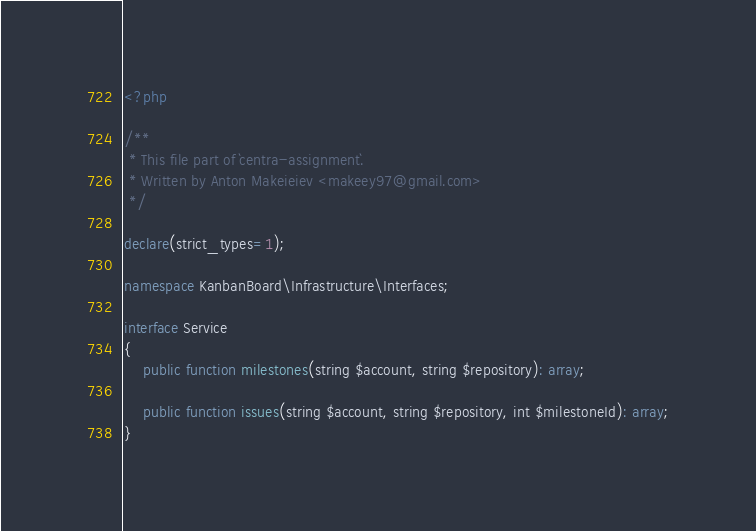Convert code to text. <code><loc_0><loc_0><loc_500><loc_500><_PHP_><?php

/**
 * This file part of `centra-assignment`.
 * Written by Anton Makeieiev <makeey97@gmail.com>
 */

declare(strict_types=1);

namespace KanbanBoard\Infrastructure\Interfaces;

interface Service
{
    public function milestones(string $account, string $repository): array;

    public function issues(string $account, string $repository, int $milestoneId): array;
}
</code> 